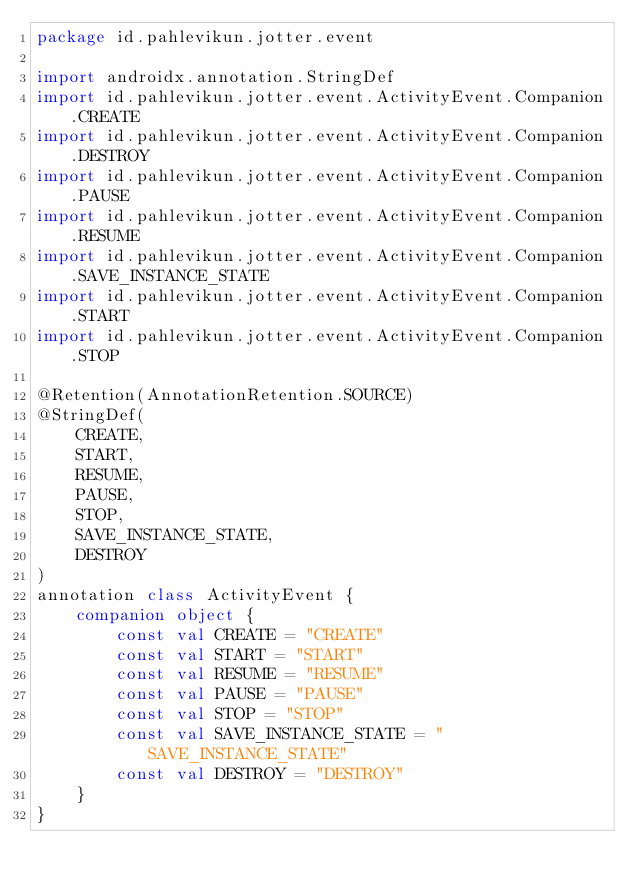Convert code to text. <code><loc_0><loc_0><loc_500><loc_500><_Kotlin_>package id.pahlevikun.jotter.event

import androidx.annotation.StringDef
import id.pahlevikun.jotter.event.ActivityEvent.Companion.CREATE
import id.pahlevikun.jotter.event.ActivityEvent.Companion.DESTROY
import id.pahlevikun.jotter.event.ActivityEvent.Companion.PAUSE
import id.pahlevikun.jotter.event.ActivityEvent.Companion.RESUME
import id.pahlevikun.jotter.event.ActivityEvent.Companion.SAVE_INSTANCE_STATE
import id.pahlevikun.jotter.event.ActivityEvent.Companion.START
import id.pahlevikun.jotter.event.ActivityEvent.Companion.STOP

@Retention(AnnotationRetention.SOURCE)
@StringDef(
    CREATE,
    START,
    RESUME,
    PAUSE,
    STOP,
    SAVE_INSTANCE_STATE,
    DESTROY
)
annotation class ActivityEvent {
    companion object {
        const val CREATE = "CREATE"
        const val START = "START"
        const val RESUME = "RESUME"
        const val PAUSE = "PAUSE"
        const val STOP = "STOP"
        const val SAVE_INSTANCE_STATE = "SAVE_INSTANCE_STATE"
        const val DESTROY = "DESTROY"
    }
}</code> 